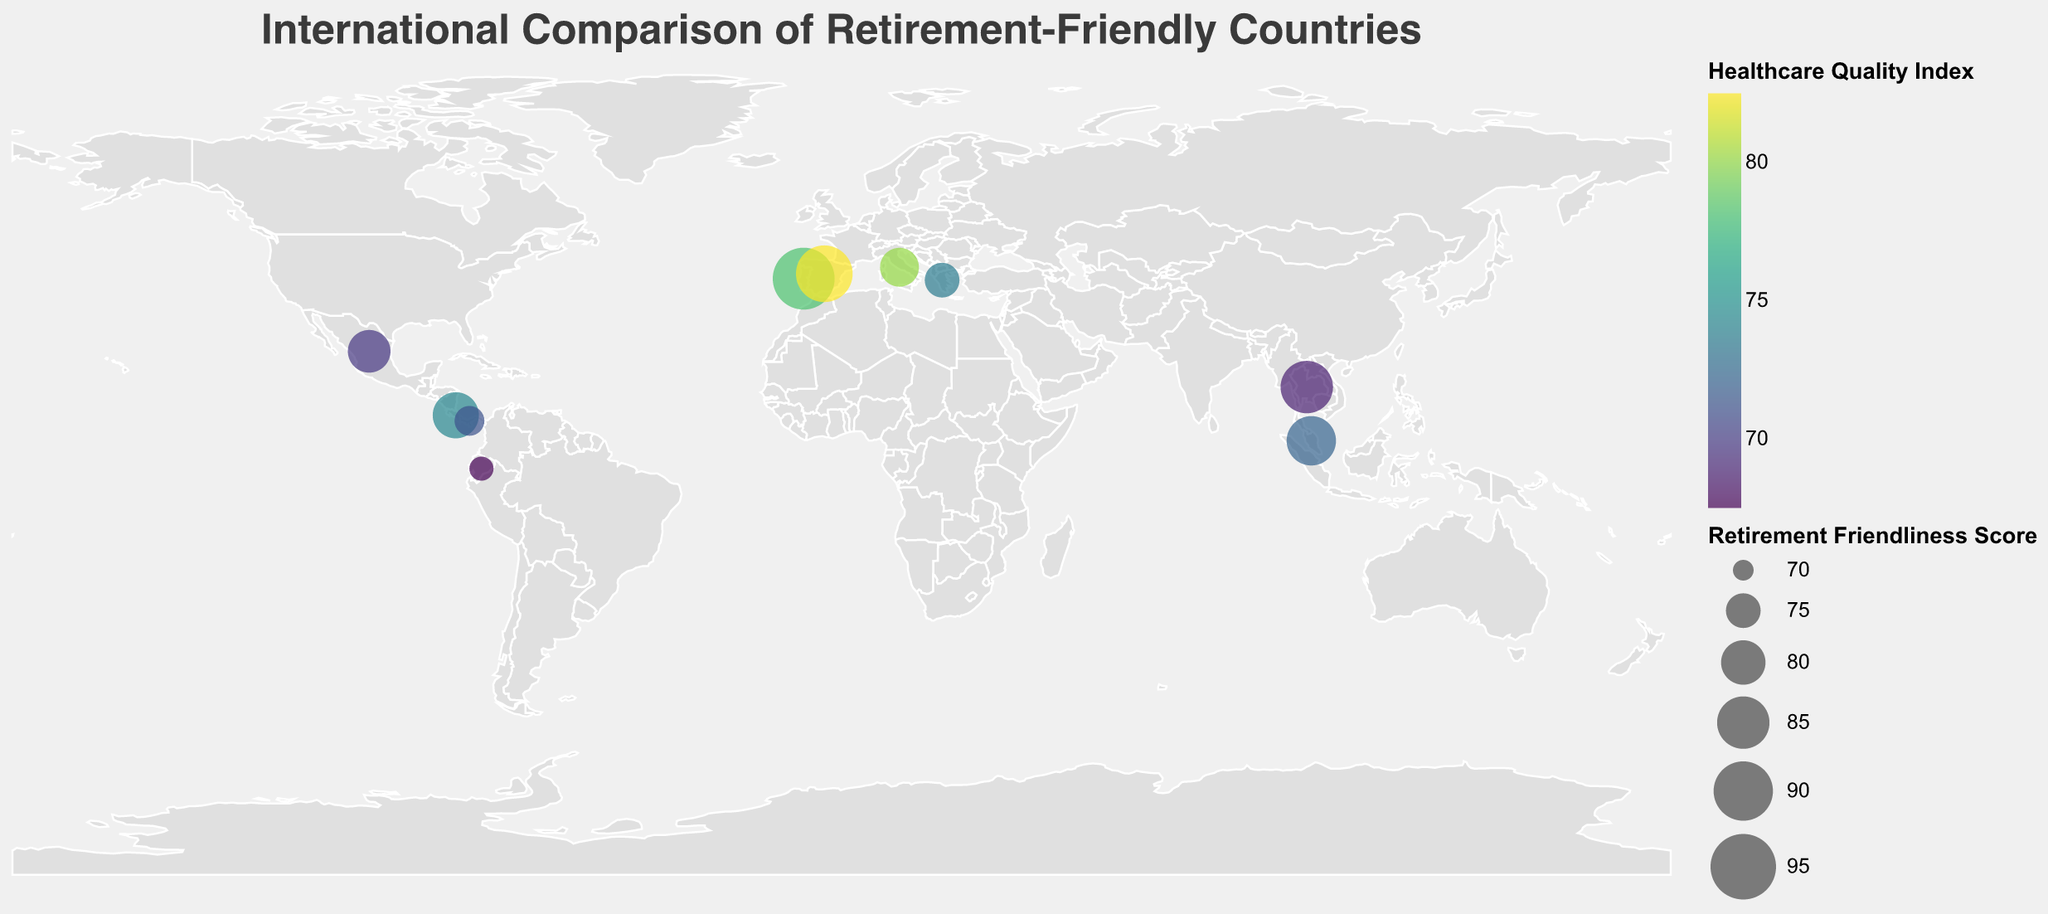What is the title of the figure? The title of the figure is displayed at the top and it reads "International Comparison of Retirement-Friendly Countries".
Answer: International Comparison of Retirement-Friendly Countries How many data points (countries) are shown in the figure? By referring to the data points displayed as circles on the map, there are 10 countries represented.
Answer: 10 Which country has the highest Retirement Friendliness Score? The size of the circles represents the Retirement Friendliness Score, and the largest circle corresponds to Portugal with a score of 92.
Answer: Portugal What color indicates the highest Healthcare Quality Index on the map? The color of the circles varies according to the Healthcare Quality Index using a viridis color scale; the lightest color, representing the highest value, appears on Spain.
Answer: Lightest color/Yellow-greenish Which country has the lowest Cost of Living Index? By examining the tooltip or the smallest value of the Cost of Living Index, Malaysia has the lowest index of 39.8.
Answer: Malaysia Which two countries are both in Latin America and have Retirement Friendliness Scores above 70? By visually locating countries in Latin America, Costa Rica and Mexico are identified on the map and both have scores above 70 as per the figure.
Answer: Costa Rica, Mexico What is the total Retirement Friendliness Score of European countries shown in the figure? Adding up the scores for Portugal (92), Spain (88), Italy (77), and Greece (75), we get 92 + 88 + 77 + 75 = 332.
Answer: 332 Compare the Healthcare Quality Index between Spain and Italy. Which one has a higher index? By examining the data points, Spain has a Healthcare Quality Index of 82.5 while Italy has 80.1, so Spain has a higher index.
Answer: Spain What is the most common range of Retirement Friendliness Scores for the countries shown? Observing the sizes of the circles, most of the Retirement Friendliness Scores fall between 70 and 85.
Answer: 70 to 85 How does the Social Activities Index compare between Portugal and Greece? By looking at the Social Activities Index in the tooltip, Portugal has a score of 85.3 and Greece has 79.8, so Portugal is higher.
Answer: Portugal 